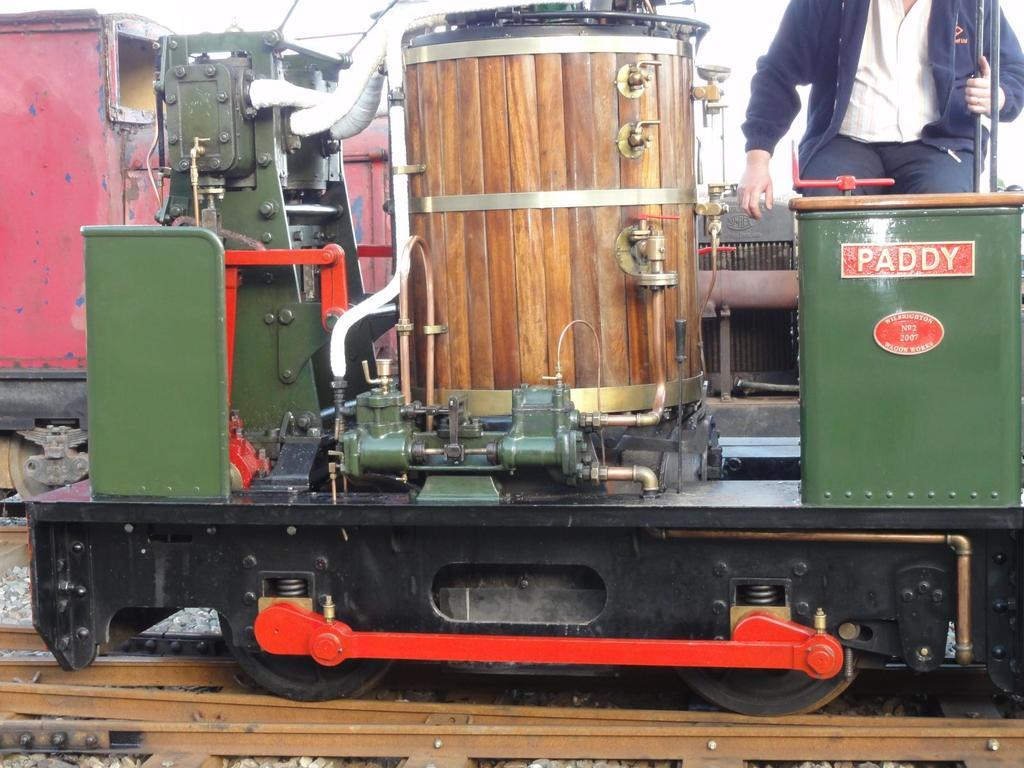What is the main object in the center of the image? There is a paddy machine in the center of the image. Can you describe any other elements in the image? Yes, there is a man in the top right side of the image. What type of structure can be seen in the background of the image? There is no structure visible in the background of the image. How many pears are present in the image? There are no pears present in the image. 